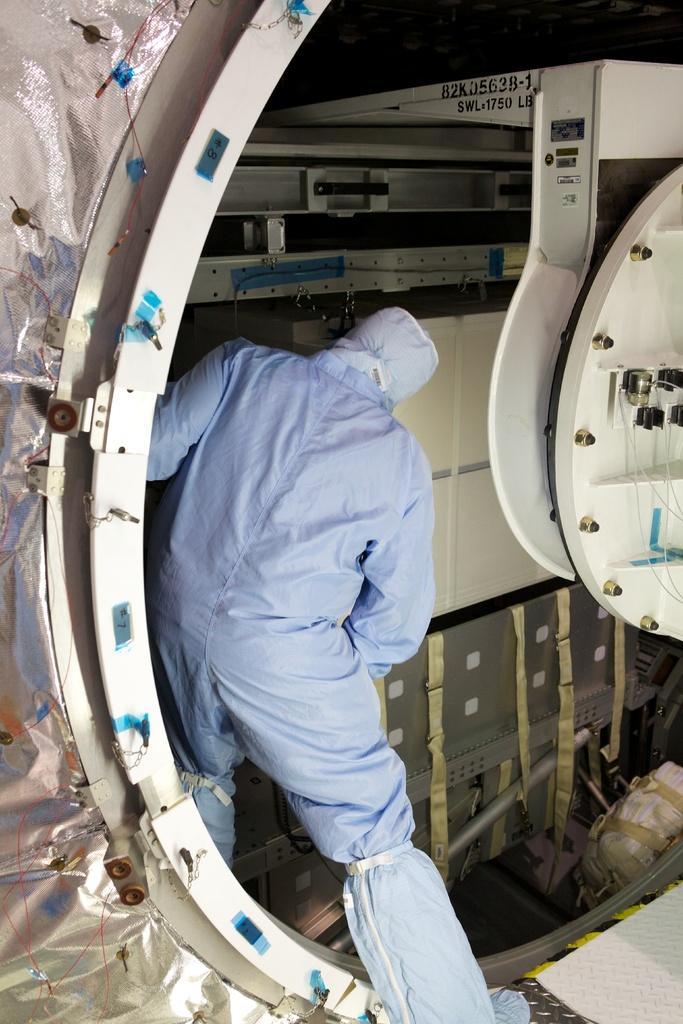Please provide a concise description of this image. In this picture I can see a human and looks like a machine in the container. 